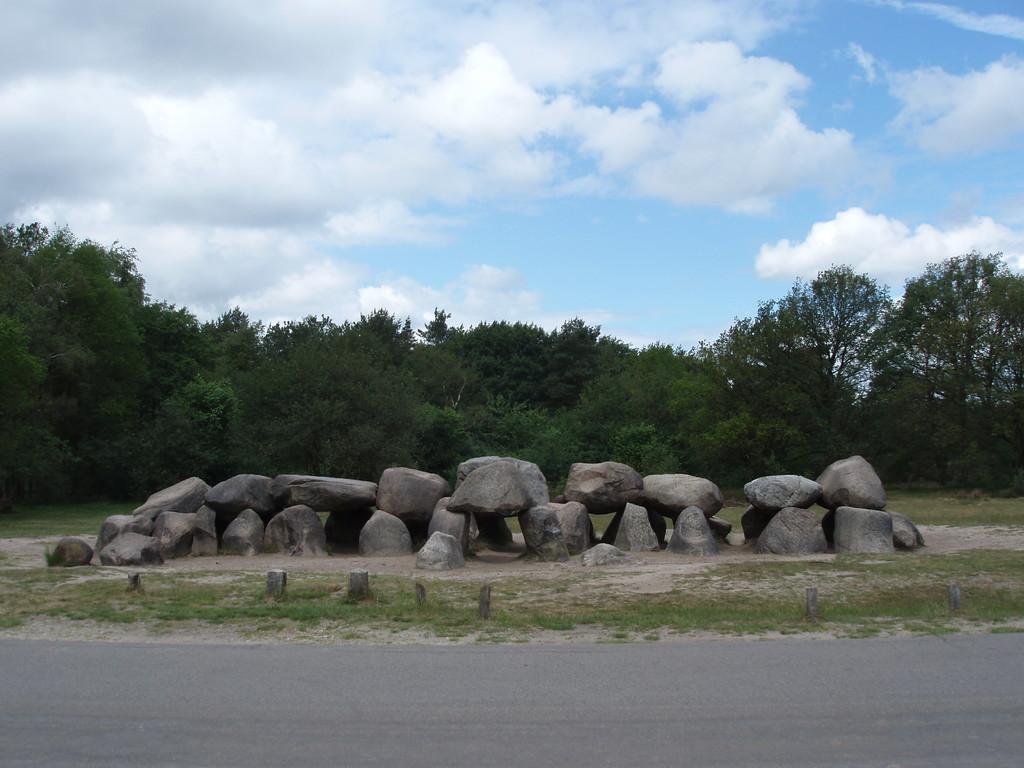Could you give a brief overview of what you see in this image? In the image there are stone rocks in the middle in front of road, in the back there are trees all over the image and above its sky with clouds. 